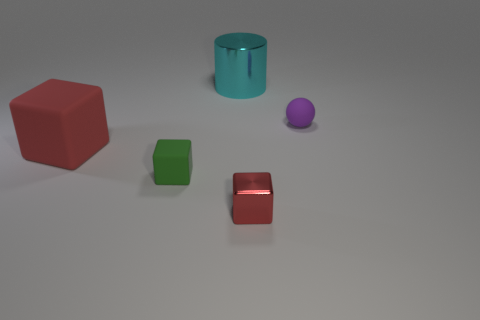There is another red thing that is the same shape as the tiny red metal thing; what is its size?
Offer a terse response. Large. What color is the cylinder that is the same material as the small red cube?
Provide a succinct answer. Cyan. There is a green thing; does it have the same size as the cube behind the small green matte cube?
Offer a terse response. No. What size is the rubber object in front of the red cube that is left of the metal thing that is behind the purple rubber thing?
Provide a short and direct response. Small. What number of shiny things are either tiny green things or blue balls?
Your answer should be compact. 0. There is a metal object that is behind the large rubber cube; what is its color?
Ensure brevity in your answer.  Cyan. There is a purple rubber object that is the same size as the green object; what shape is it?
Your answer should be very brief. Sphere. Do the small matte block and the small matte thing behind the tiny green rubber thing have the same color?
Ensure brevity in your answer.  No. What number of objects are objects that are behind the large red object or objects that are in front of the cyan cylinder?
Make the answer very short. 5. What material is the red object that is the same size as the cyan cylinder?
Ensure brevity in your answer.  Rubber. 